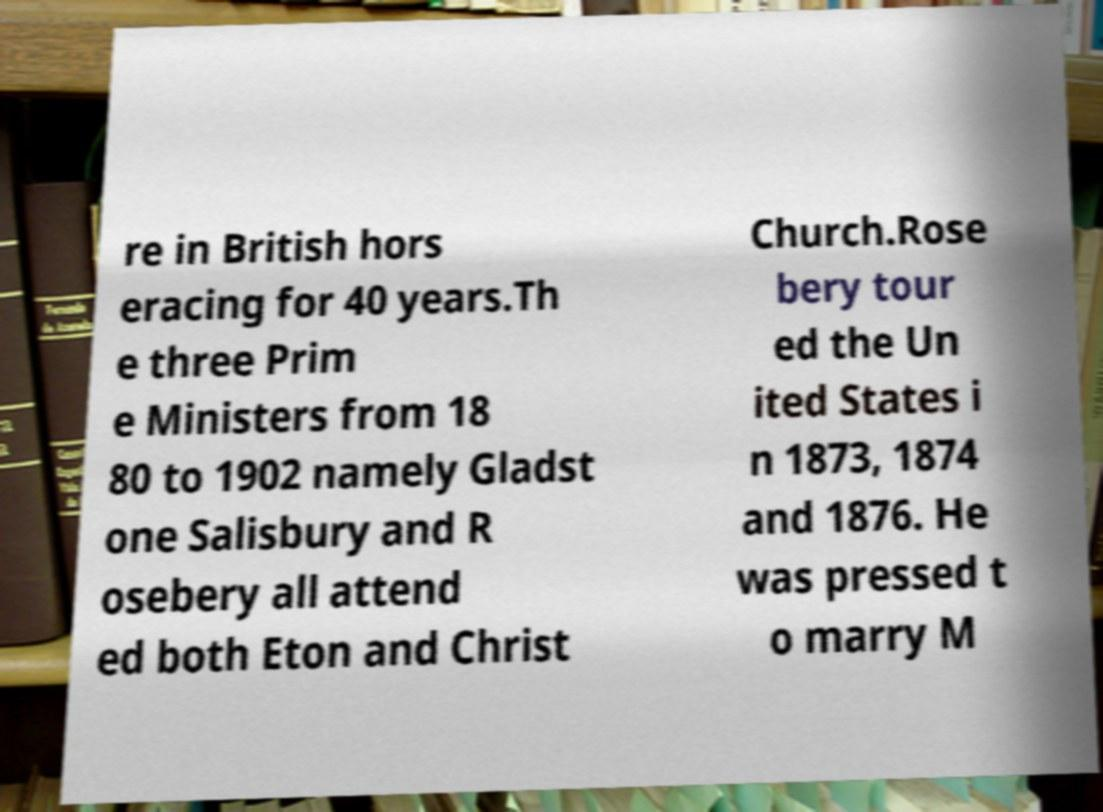I need the written content from this picture converted into text. Can you do that? re in British hors eracing for 40 years.Th e three Prim e Ministers from 18 80 to 1902 namely Gladst one Salisbury and R osebery all attend ed both Eton and Christ Church.Rose bery tour ed the Un ited States i n 1873, 1874 and 1876. He was pressed t o marry M 